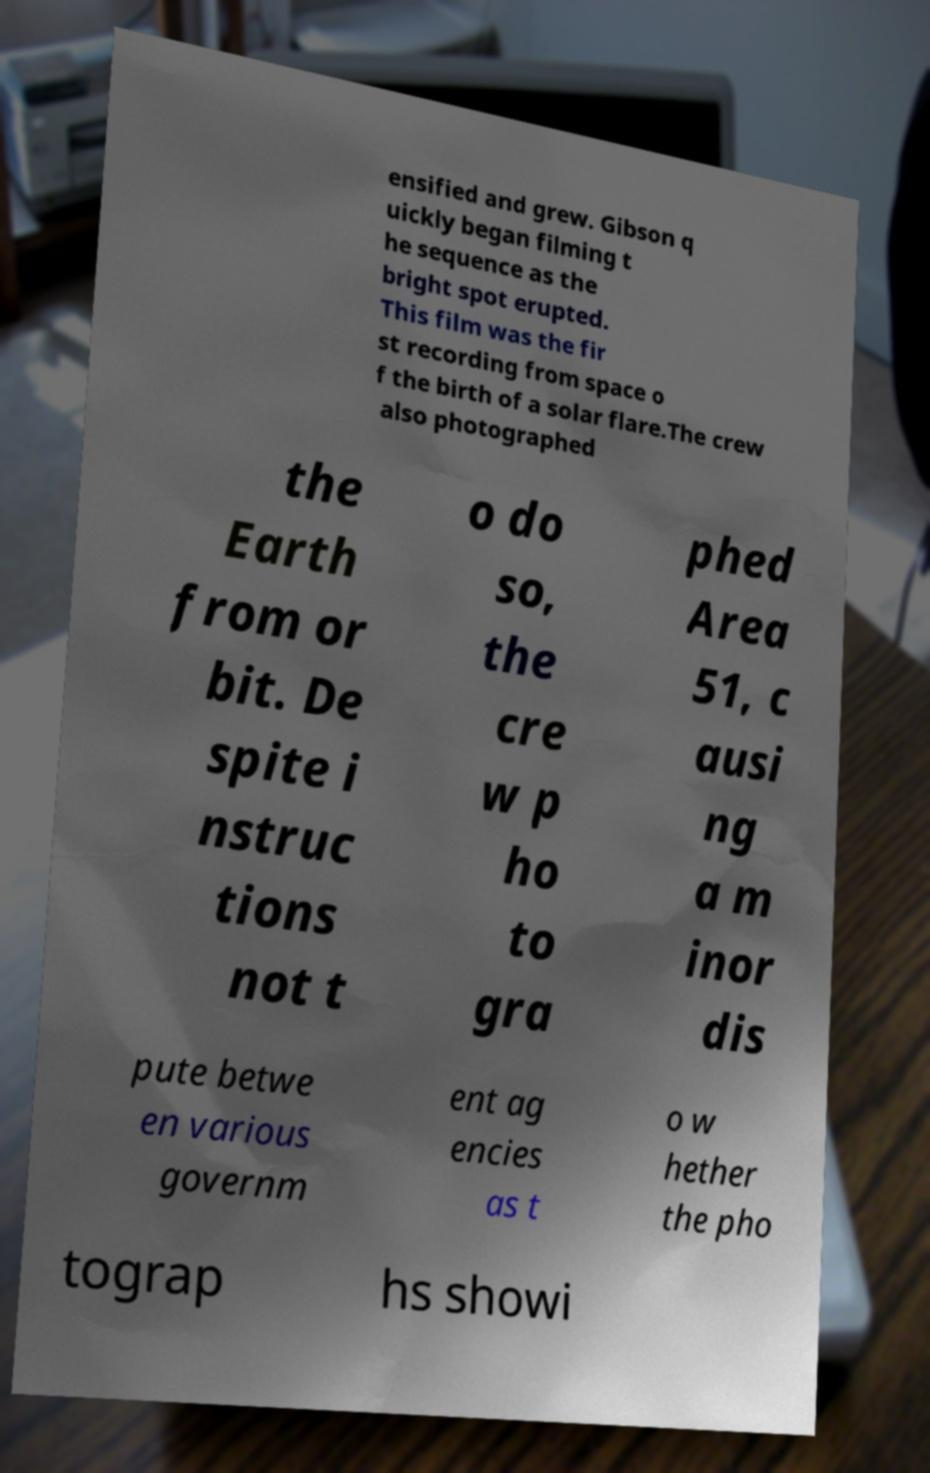Please identify and transcribe the text found in this image. ensified and grew. Gibson q uickly began filming t he sequence as the bright spot erupted. This film was the fir st recording from space o f the birth of a solar flare.The crew also photographed the Earth from or bit. De spite i nstruc tions not t o do so, the cre w p ho to gra phed Area 51, c ausi ng a m inor dis pute betwe en various governm ent ag encies as t o w hether the pho tograp hs showi 